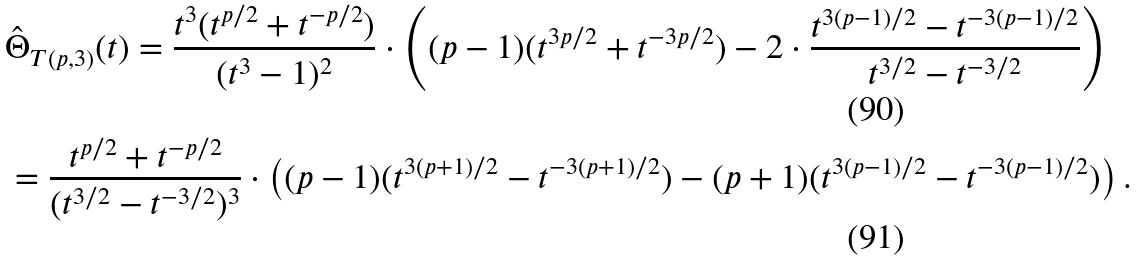Convert formula to latex. <formula><loc_0><loc_0><loc_500><loc_500>& \hat { \Theta } _ { T ( p , 3 ) } ( t ) = \frac { t ^ { 3 } ( t ^ { p / 2 } + t ^ { - p / 2 } ) } { ( t ^ { 3 } - 1 ) ^ { 2 } } \cdot \left ( ( p - 1 ) ( t ^ { 3 p / 2 } + t ^ { - 3 p / 2 } ) - 2 \cdot \frac { t ^ { 3 ( p - 1 ) / 2 } - t ^ { - 3 ( p - 1 ) / 2 } } { t ^ { 3 / 2 } - t ^ { - 3 / 2 } } \right ) \\ & = \frac { t ^ { p / 2 } + t ^ { - p / 2 } } { ( t ^ { 3 / 2 } - t ^ { - 3 / 2 } ) ^ { 3 } } \cdot \left ( ( p - 1 ) ( t ^ { 3 ( p + 1 ) / 2 } - t ^ { - 3 ( p + 1 ) / 2 } ) - ( p + 1 ) ( t ^ { 3 ( p - 1 ) / 2 } - t ^ { - 3 ( p - 1 ) / 2 } ) \right ) .</formula> 